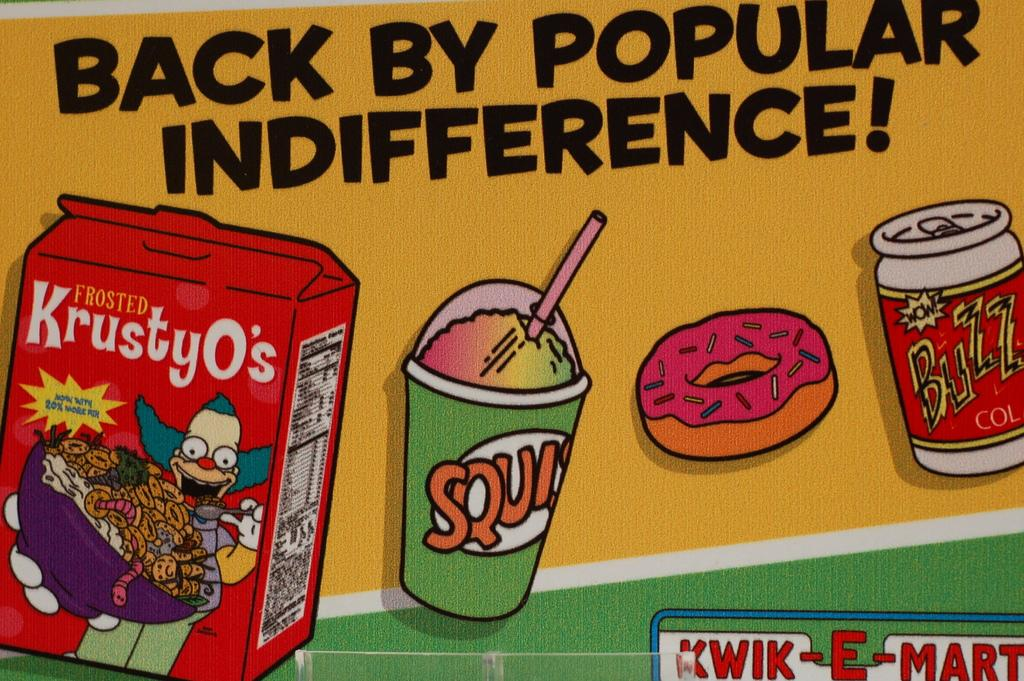<image>
Provide a brief description of the given image. A Kwik-E-Mart ad showing KrustyO's and a drink and a donut. 